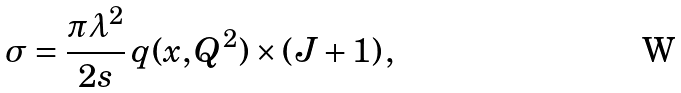Convert formula to latex. <formula><loc_0><loc_0><loc_500><loc_500>\sigma = \frac { \pi \lambda ^ { 2 } } { 2 s } \, q ( x , Q ^ { 2 } ) \times ( J + 1 ) \, ,</formula> 